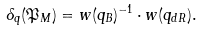Convert formula to latex. <formula><loc_0><loc_0><loc_500><loc_500>\delta _ { q } ( \mathfrak { P } _ { M } ) = w ( q _ { B } ) ^ { - 1 } \cdot w ( q _ { d R } ) .</formula> 